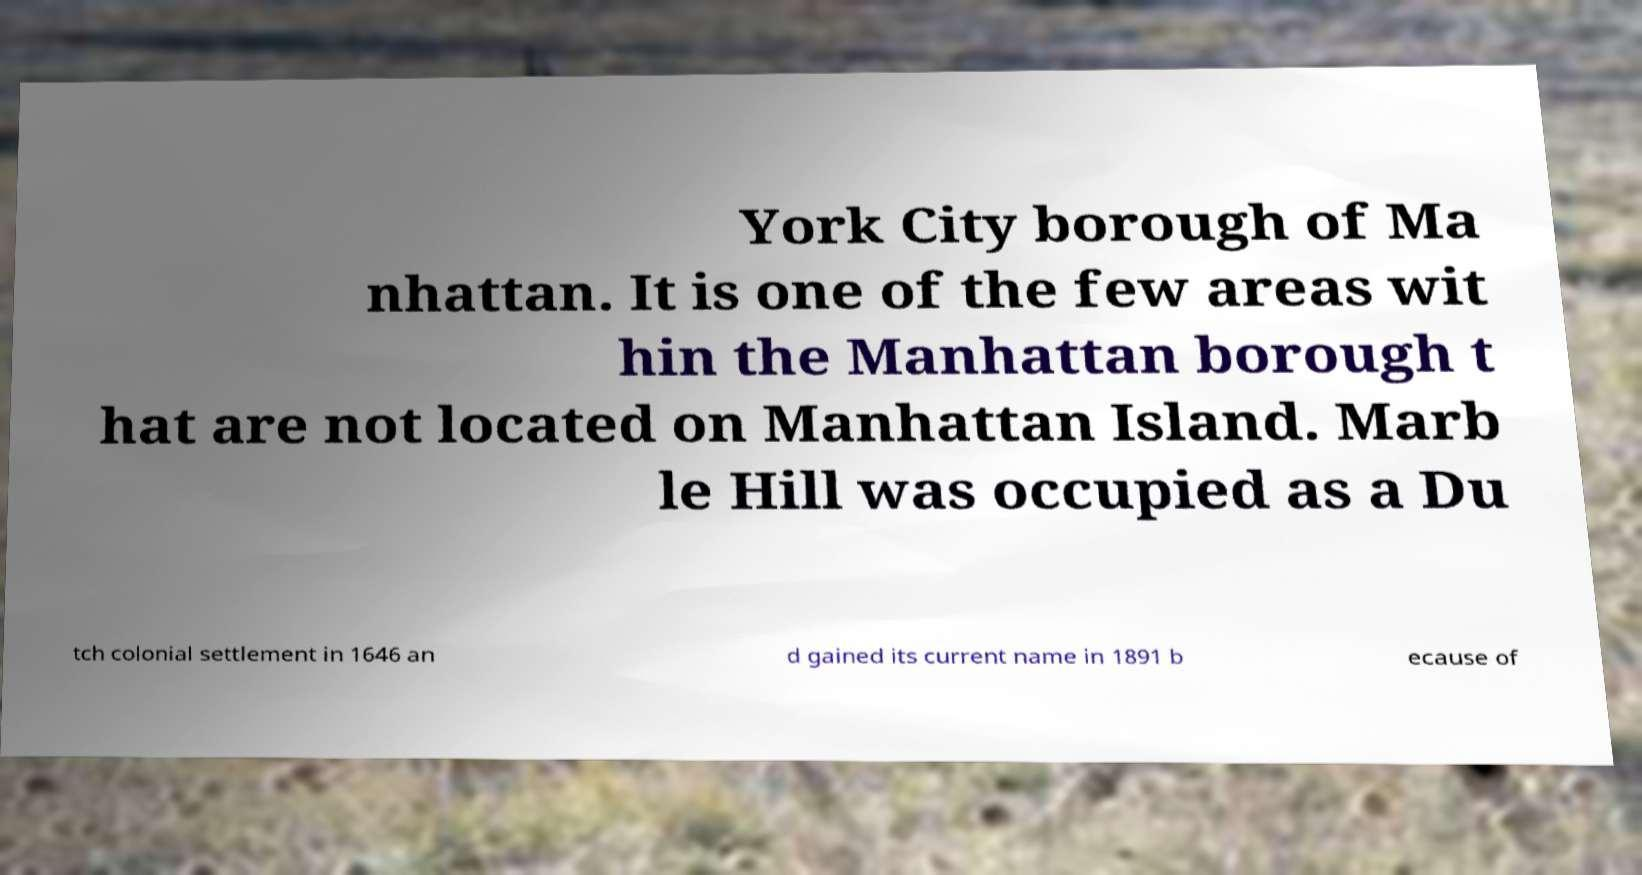I need the written content from this picture converted into text. Can you do that? York City borough of Ma nhattan. It is one of the few areas wit hin the Manhattan borough t hat are not located on Manhattan Island. Marb le Hill was occupied as a Du tch colonial settlement in 1646 an d gained its current name in 1891 b ecause of 